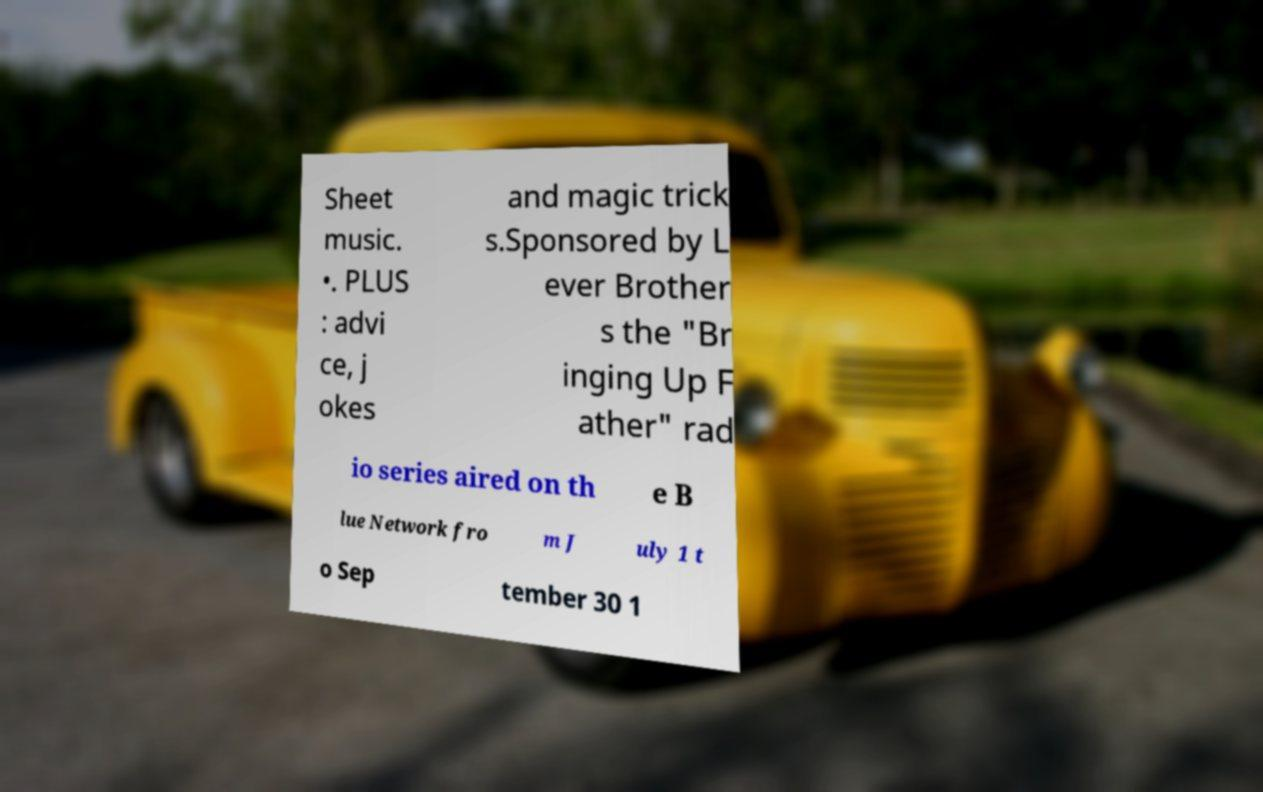Please identify and transcribe the text found in this image. Sheet music. •. PLUS : advi ce, j okes and magic trick s.Sponsored by L ever Brother s the "Br inging Up F ather" rad io series aired on th e B lue Network fro m J uly 1 t o Sep tember 30 1 